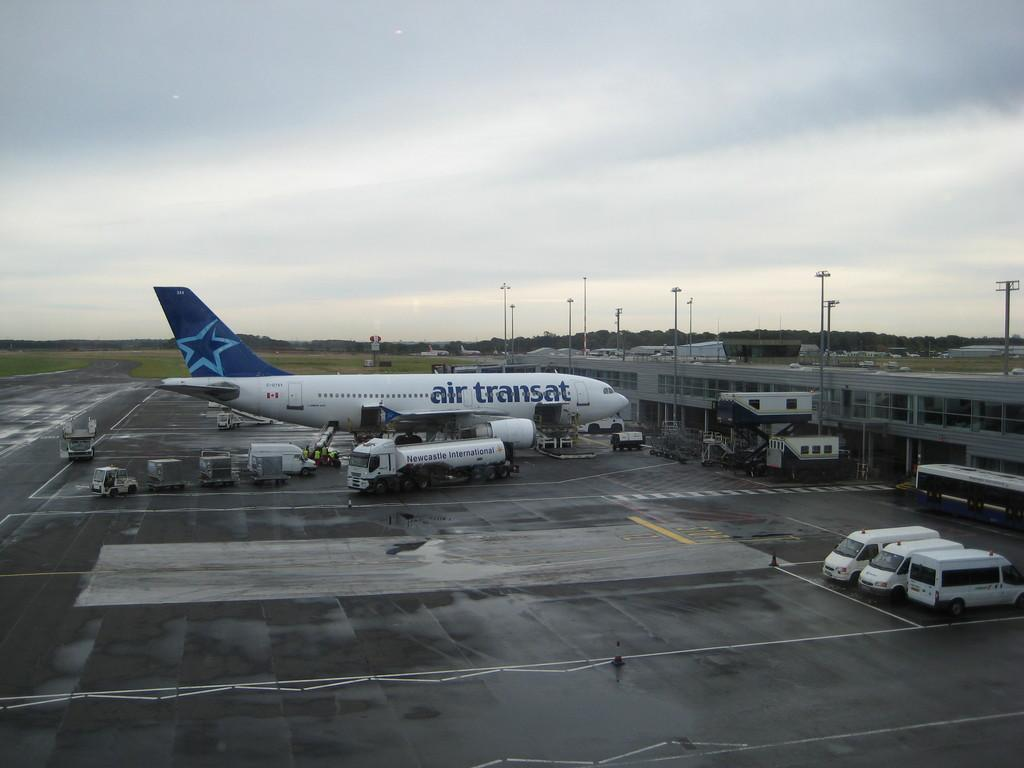<image>
Share a concise interpretation of the image provided. the words air transat are on the side of a plane 